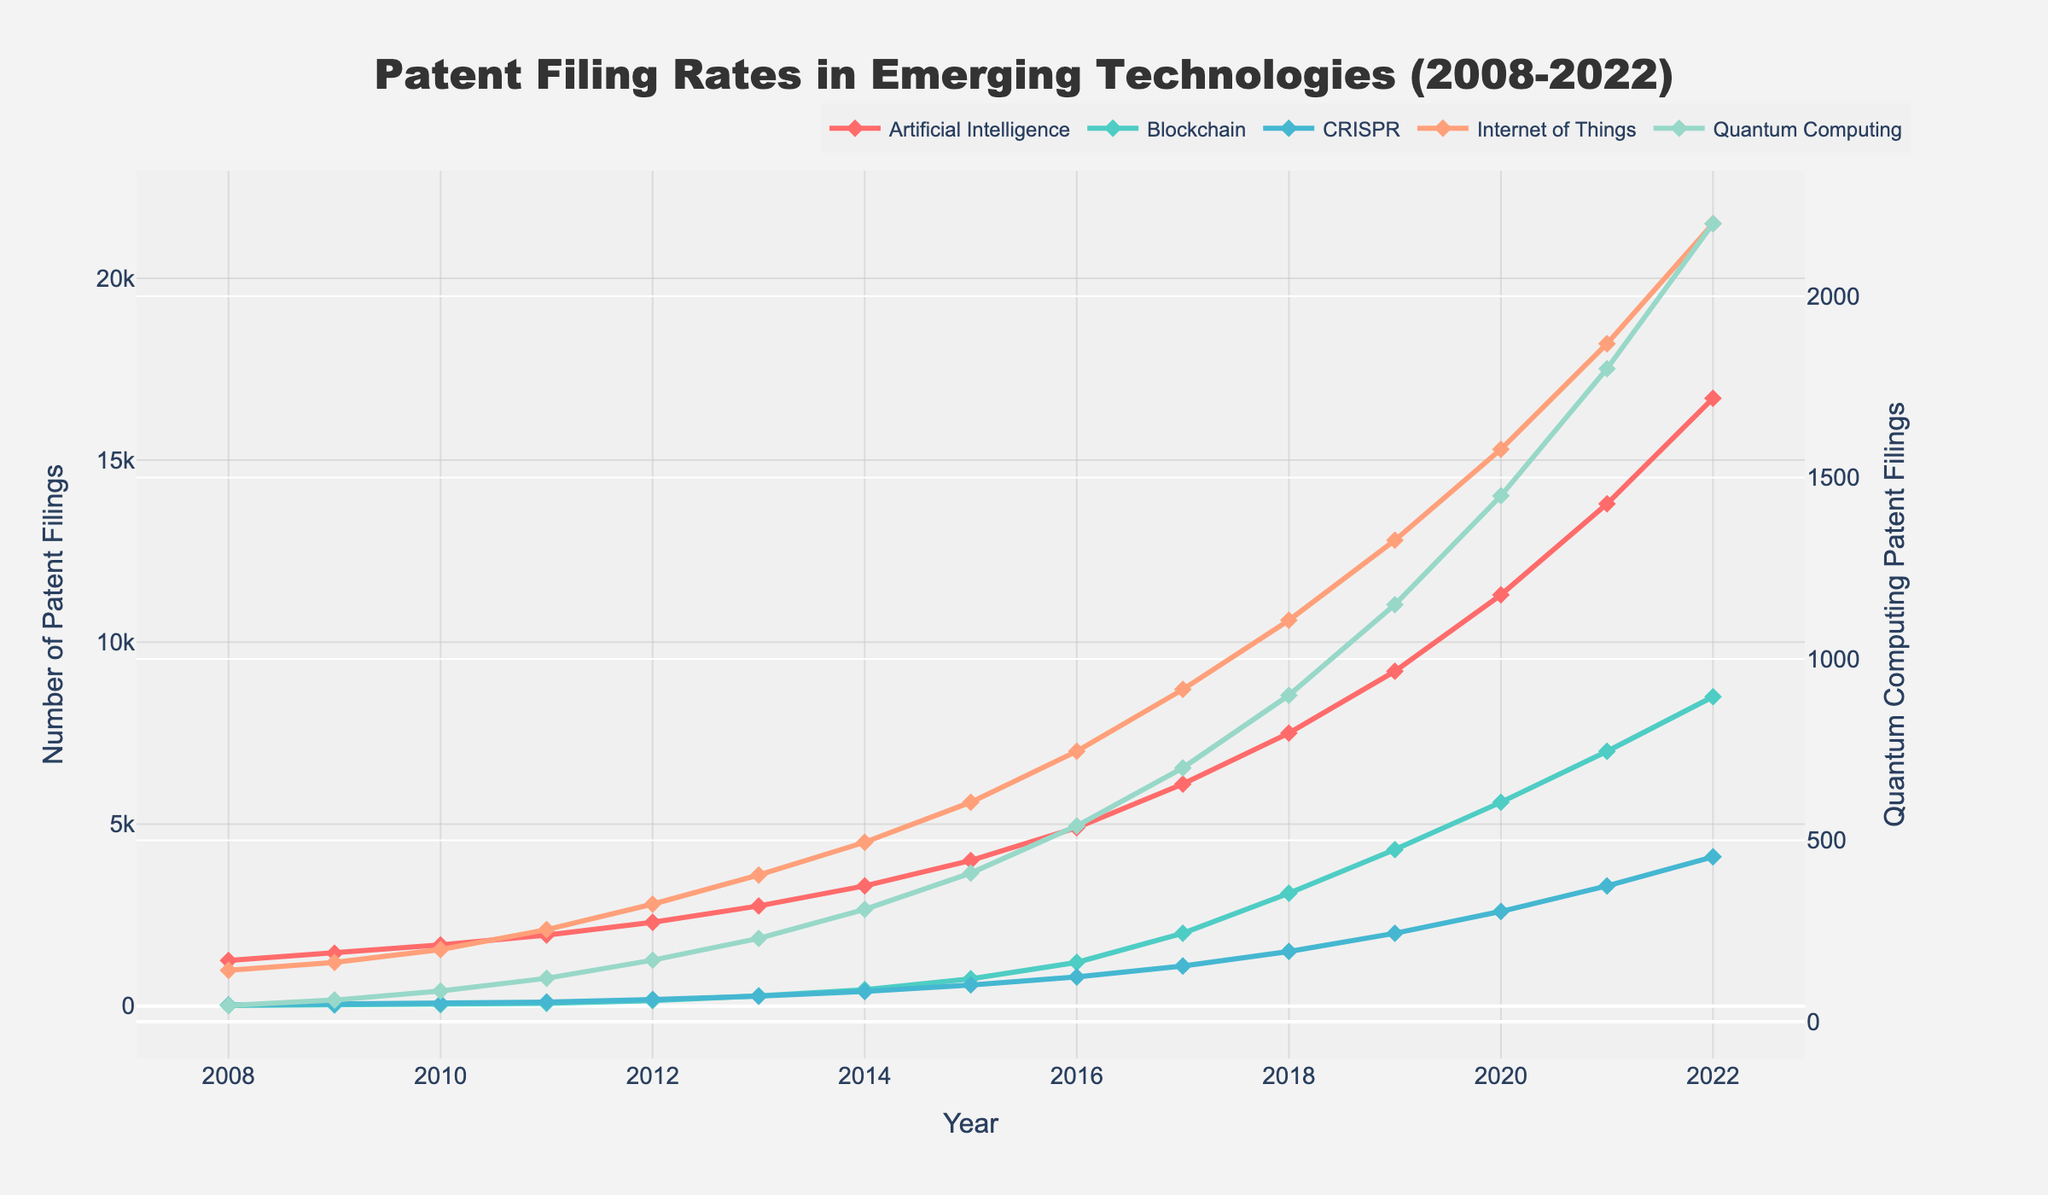1. What is the overall trend for patent filings in Artificial Intelligence from 2008 to 2022? From 2008 to 2022, the number of patent filings in Artificial Intelligence steadily increases. Starting at 1250 in 2008, the numbers rise each year, reaching 16700 by 2022.
Answer: Steady increase 2. How do the patent filing rates for Blockchain and CRISPR compare in 2015? In 2015, the number of patent filings is 750 for Blockchain and 580 for CRISPR. Comparing these values shows that Blockchain had higher patent filings than CRISPR in that year.
Answer: Blockchain > CRISPR 3. What are the two technologies with the highest patent filing rates in 2022 and what are their values? In 2022, Internet of Things has the highest value with 21500 filings, followed by Artificial Intelligence with 16700 filings.
Answer: Internet of Things: 21500, Artificial Intelligence: 16700 4. Which year did Quantum Computing patent filings first exceed 1000? Quantum Computing patent filings first exceed 1000 in 2017, with the value reaching 1150.
Answer: 2017 5. What is the difference in patent filings between Artificial Intelligence and Internet of Things in 2020? In 2020, Artificial Intelligence had 11300 filings and Internet of Things had 15300 filings. The difference is 15300 - 11300 = 4000.
Answer: 4000 6. By how much did CRISPR patent filings increase from 2010 to 2012? In 2010, CRISPR had 70 filings, and in 2012, it had 180. The increase is 180 - 70 = 110.
Answer: 110 7. What is the average number of patent filings for Quantum Computing from 2018 to 2022? Patent filings for Quantum Computing in 2018 to 2022 are 900, 1150, 1450, 1800, and 2200. The sum is 900 + 1150 + 1450 + 1800 + 2200 = 7500, and the average is 7500 / 5 = 1500.
Answer: 1500 8. Which technology had the largest growth in patent filings between 2018 and 2022? By calculating the difference in filings from 2018 to 2022 for each technology: AI (16700 - 7500 = 9200), Blockchain (8500 - 3100 = 5400), CRISPR (4100 - 1500 = 2600), IoT (21500 - 10600 = 10900), Quantum Computing (2200 - 900 = 1300). Internet of Things had the largest growth with an increase of 10900.
Answer: Internet of Things 9. What are the visual distinct features of each technology in the line chart? Artificial Intelligence is depicted with red lines and diamond markers, Blockchain with green lines and diamond markers, CRISPR with blue lines and diamond markers, Internet of Things with orange lines and diamond markers, and Quantum Computing with teal lines and diamond markers.
Answer: Color and markers 10. How does the patent filing trend for Internet of Things compare to Blockchain from 2008 to 2022? Both Internet of Things and Blockchain show an increasing trend in patent filings from 2008 to 2022. However, Internet of Things has significantly higher values throughout the entire period.
Answer: Both increasing, IoT higher 